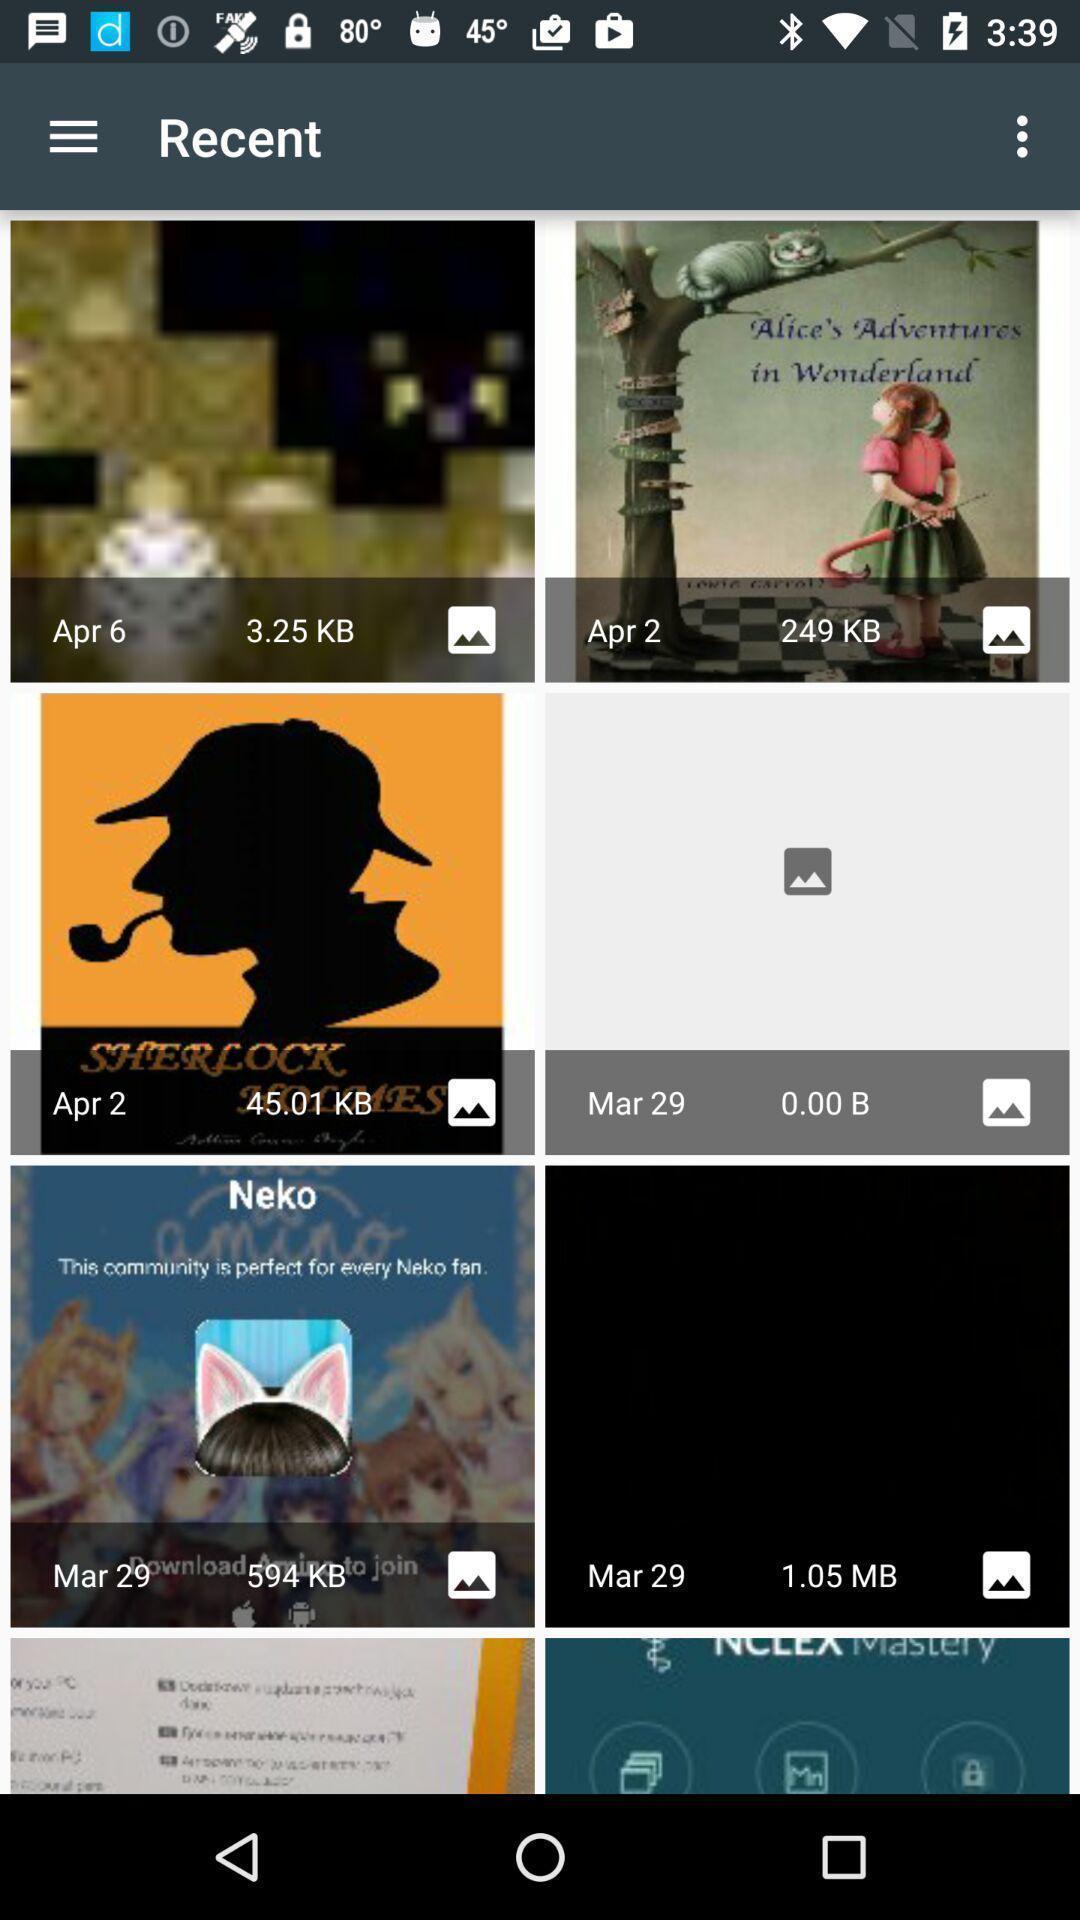What is the overall content of this screenshot? Screen shows recent images. 